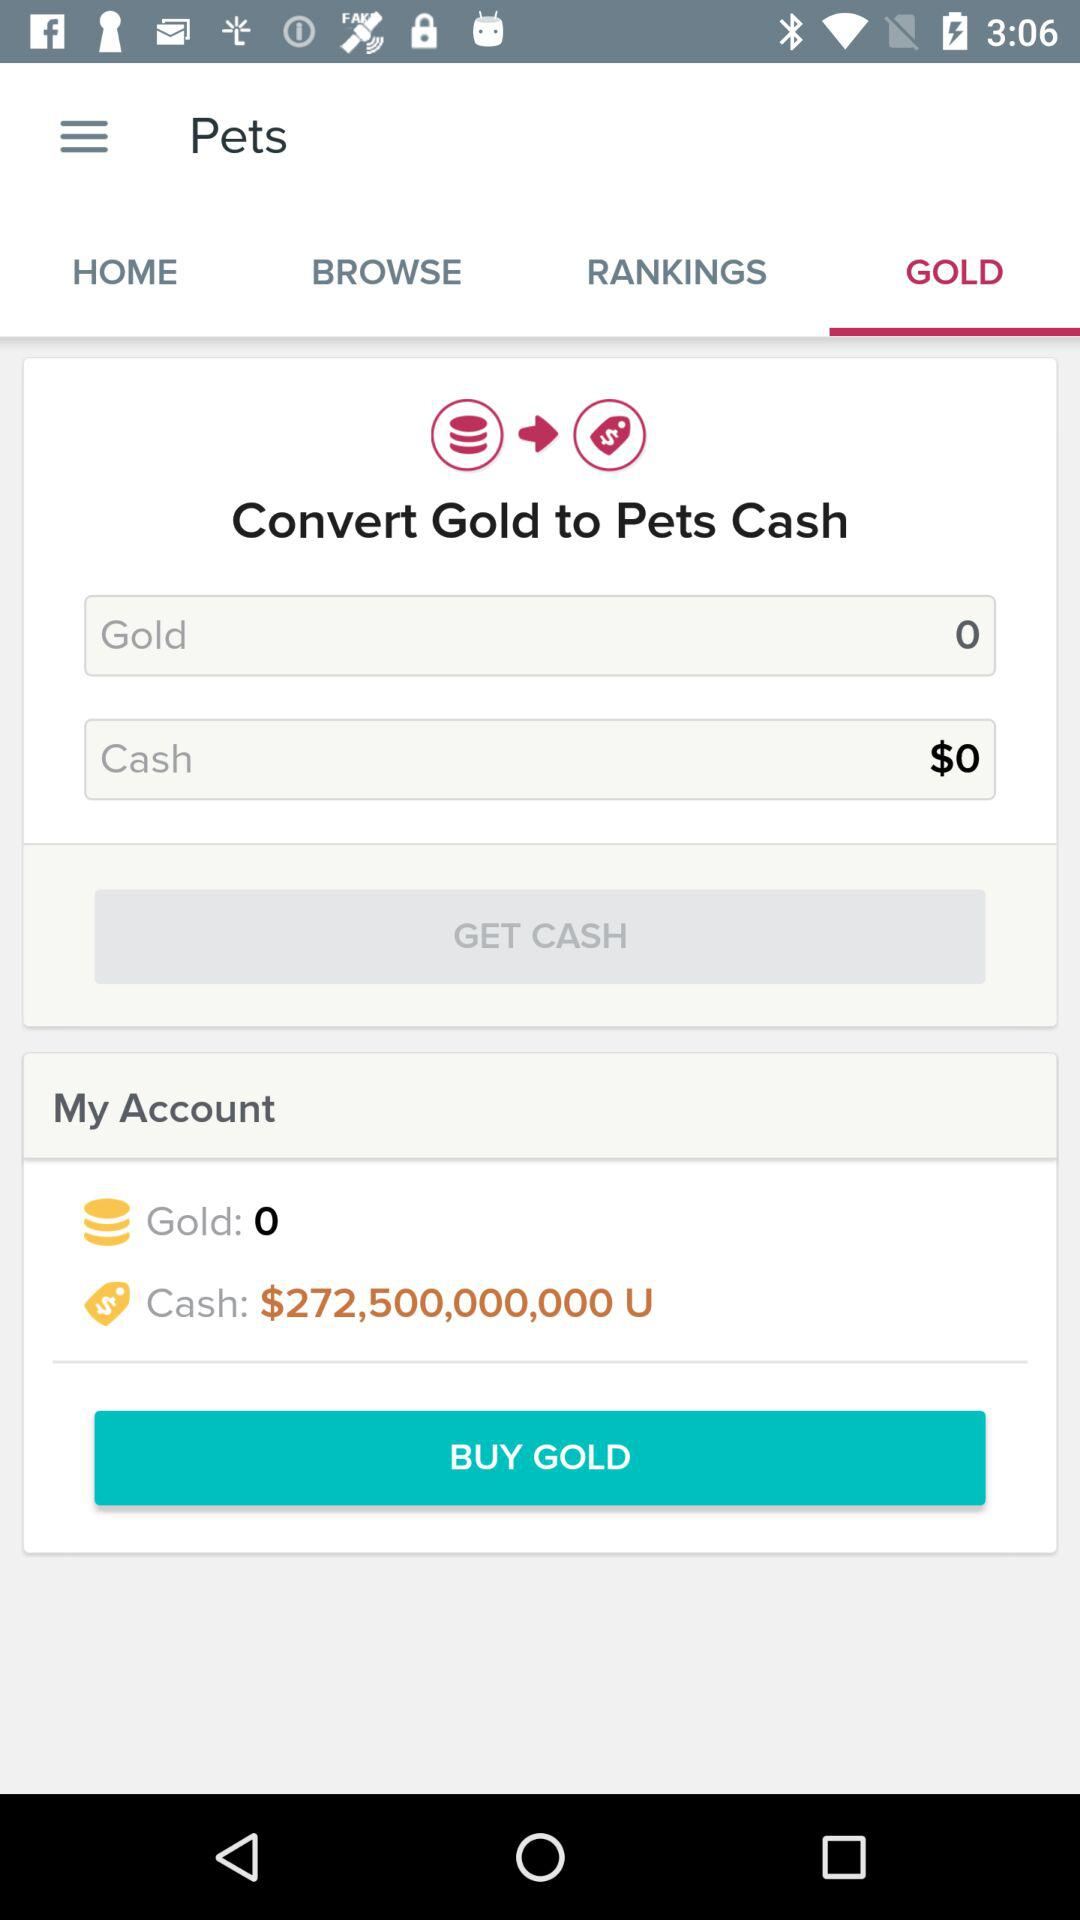How much cash do I have?
Answer the question using a single word or phrase. $272,500,000,000 U 